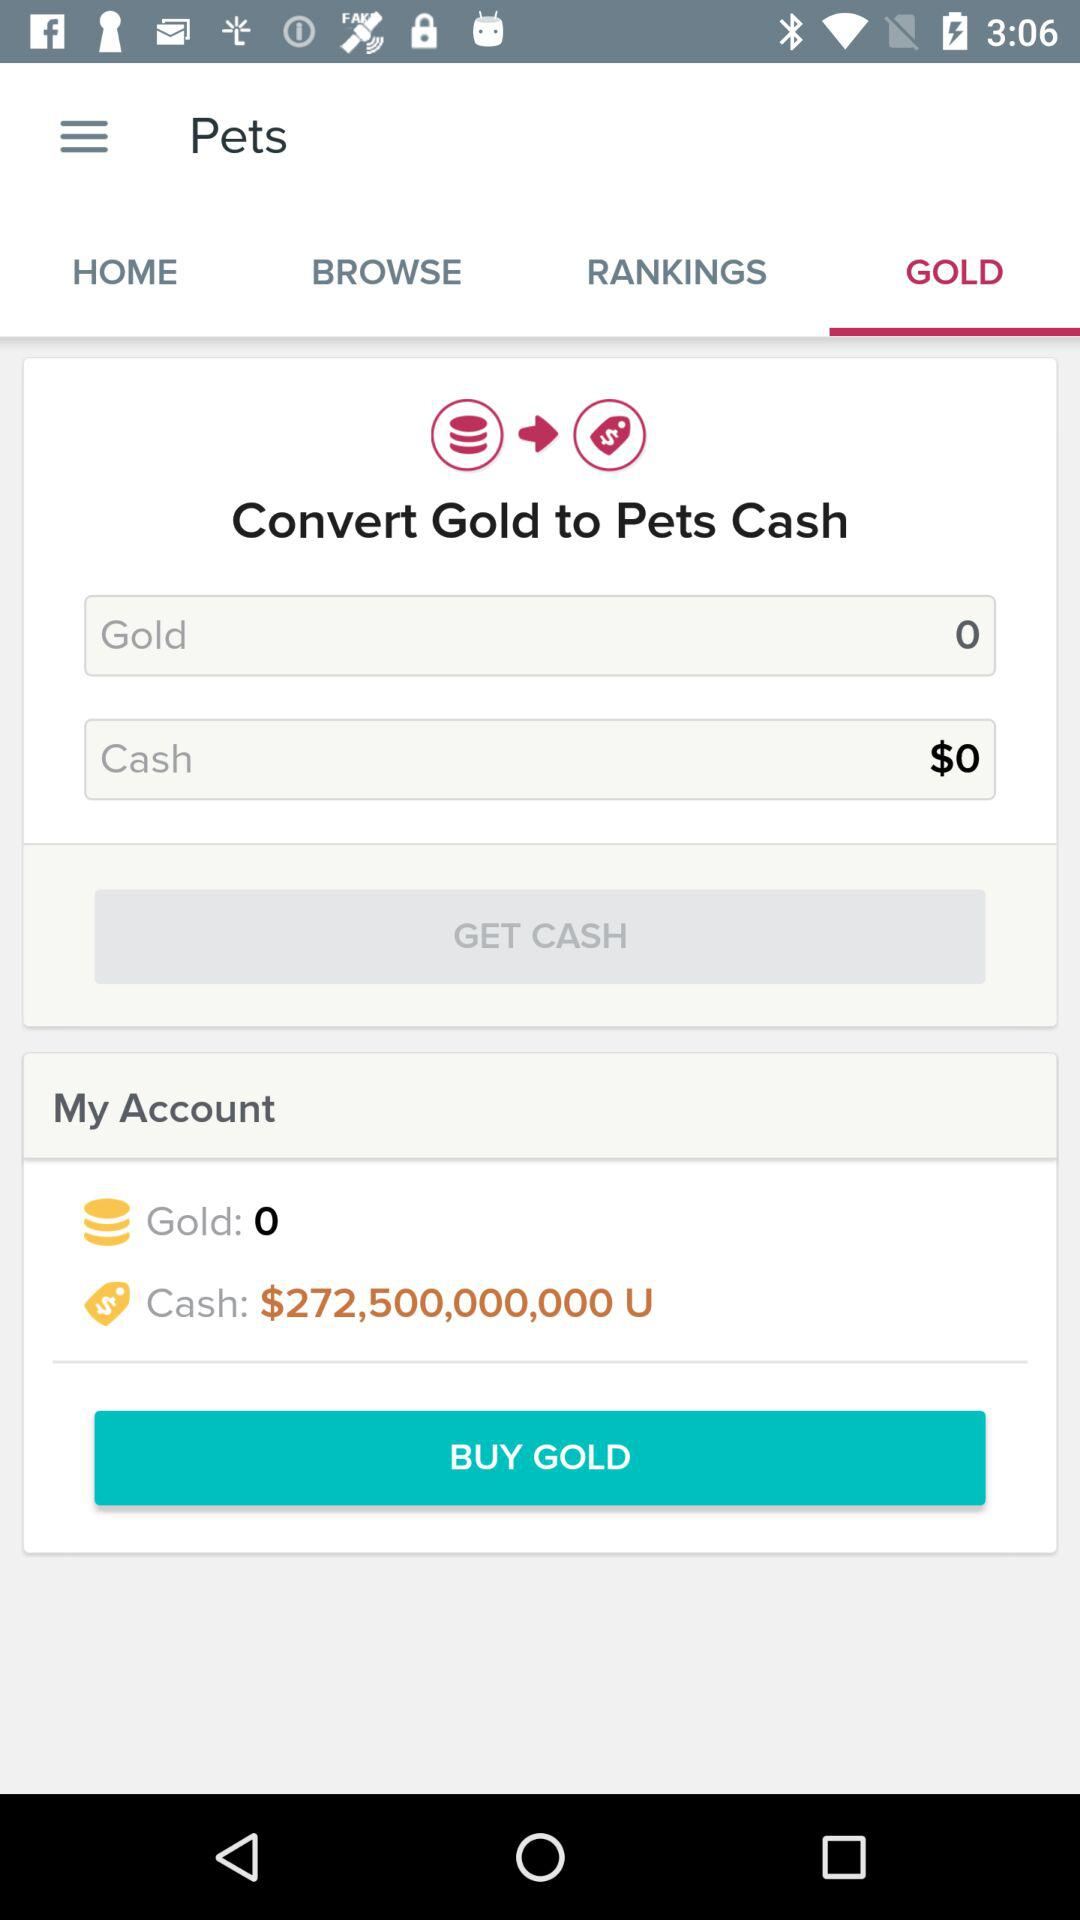How much cash do I have?
Answer the question using a single word or phrase. $272,500,000,000 U 